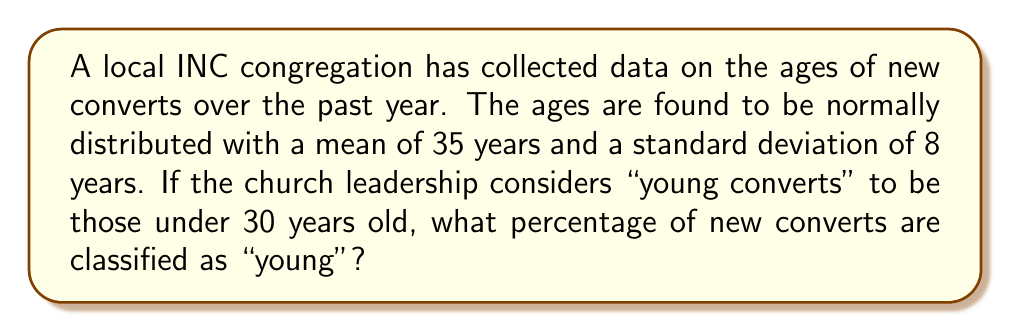Teach me how to tackle this problem. Let's approach this step-by-step:

1) We are dealing with a normal distribution where:
   $\mu = 35$ (mean age)
   $\sigma = 8$ (standard deviation of ages)

2) We need to find the probability that a new convert is under 30 years old.

3) To do this, we need to calculate the z-score for age 30:

   $$z = \frac{x - \mu}{\sigma} = \frac{30 - 35}{8} = -0.625$$

4) This z-score represents how many standard deviations 30 is below the mean.

5) Now, we need to find the area under the standard normal curve to the left of z = -0.625.

6) Using a standard normal table or calculator, we find:
   $P(Z < -0.625) \approx 0.2660$

7) This means approximately 26.60% of the area under the curve is to the left of z = -0.625.

8) Therefore, about 26.60% of new converts are under 30 years old.
Answer: 26.60% 